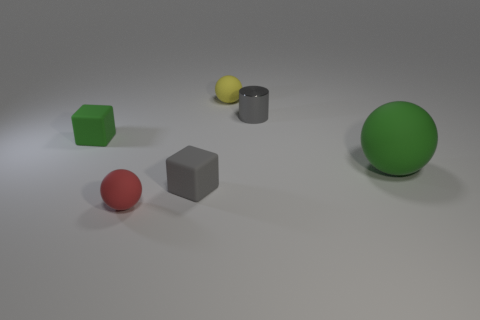There is a tiny red rubber thing; what number of small metal things are to the left of it?
Your answer should be very brief. 0. Is the number of blocks to the right of the big rubber sphere the same as the number of tiny matte objects left of the green block?
Your answer should be very brief. Yes. There is a tiny thing that is behind the small metallic thing; is it the same shape as the small metal thing?
Your answer should be compact. No. Are there any other things that have the same material as the small red object?
Give a very brief answer. Yes. There is a green rubber block; is its size the same as the gray thing that is left of the gray cylinder?
Your answer should be very brief. Yes. There is a gray metal cylinder; are there any tiny yellow matte objects to the right of it?
Offer a terse response. No. How many objects are either green cubes or small objects in front of the small green matte block?
Keep it short and to the point. 3. Are there any small red balls that are behind the gray matte block in front of the green ball?
Keep it short and to the point. No. The gray object to the right of the small matte cube that is right of the small rubber cube that is on the left side of the small red rubber ball is what shape?
Your response must be concise. Cylinder. What color is the object that is both in front of the yellow ball and behind the green cube?
Ensure brevity in your answer.  Gray. 